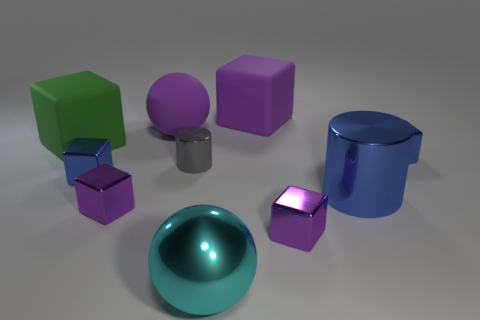There is a purple rubber cube that is on the right side of the large purple sphere; what size is it?
Keep it short and to the point. Large. How many tiny blue shiny things are the same shape as the tiny gray shiny thing?
Provide a succinct answer. 0. The gray object that is made of the same material as the cyan ball is what shape?
Your response must be concise. Cylinder. How many blue things are either tiny metallic cylinders or metallic spheres?
Provide a short and direct response. 0. There is a big rubber ball; are there any big rubber blocks in front of it?
Offer a very short reply. Yes. Does the tiny blue object on the right side of the gray metallic cylinder have the same shape as the big cyan shiny object that is left of the big blue cylinder?
Provide a succinct answer. No. There is a large purple thing that is the same shape as the big green object; what is its material?
Your answer should be compact. Rubber. What number of cylinders are either purple rubber objects or cyan objects?
Keep it short and to the point. 0. What number of tiny gray cylinders have the same material as the green object?
Offer a terse response. 0. Do the purple block to the left of the large purple matte block and the blue block on the right side of the cyan metal ball have the same material?
Keep it short and to the point. Yes. 